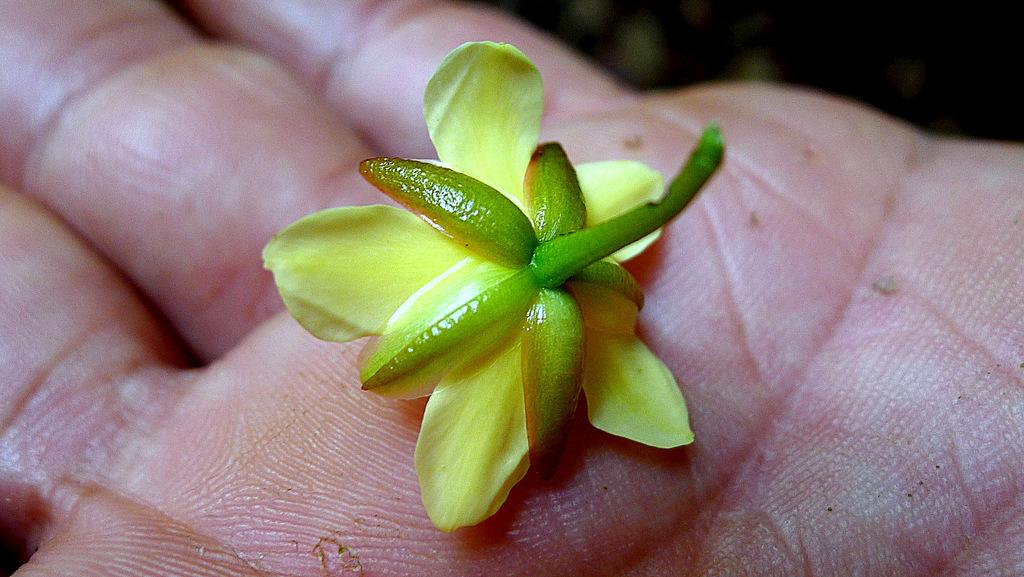What is the main subject of the image? There is a flower in the image. Where is the flower located? The flower is on a person's hand. Can you describe the top part of the image? The top part of the image is blurred. What type of letters can be seen in the image? There are no letters present in the image; it features a flower on a person's hand and a blurred top part. What is the flower being used for in the image? The image does not provide information about the purpose or use of the flower. 